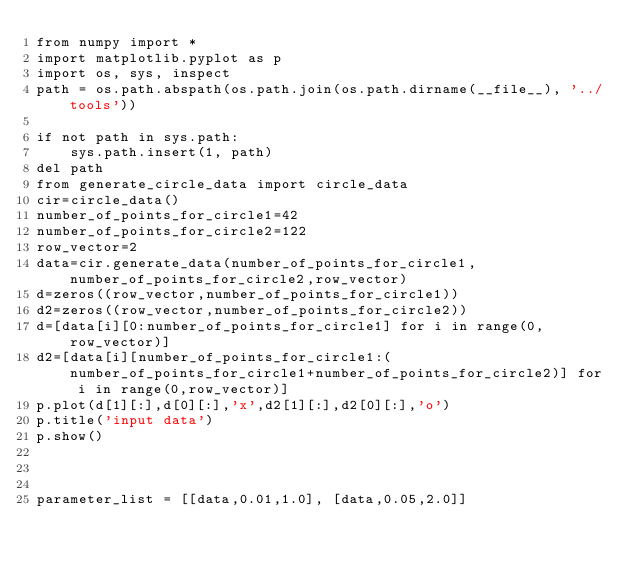<code> <loc_0><loc_0><loc_500><loc_500><_Python_>from numpy import *
import matplotlib.pyplot as p
import os, sys, inspect
path = os.path.abspath(os.path.join(os.path.dirname(__file__), '../tools'))

if not path in sys.path:
    sys.path.insert(1, path)
del path
from generate_circle_data import circle_data
cir=circle_data()
number_of_points_for_circle1=42
number_of_points_for_circle2=122
row_vector=2
data=cir.generate_data(number_of_points_for_circle1,number_of_points_for_circle2,row_vector)
d=zeros((row_vector,number_of_points_for_circle1))
d2=zeros((row_vector,number_of_points_for_circle2))
d=[data[i][0:number_of_points_for_circle1] for i in range(0,row_vector)]
d2=[data[i][number_of_points_for_circle1:(number_of_points_for_circle1+number_of_points_for_circle2)] for i in range(0,row_vector)]
p.plot(d[1][:],d[0][:],'x',d2[1][:],d2[0][:],'o')
p.title('input data')
p.show()



parameter_list = [[data,0.01,1.0], [data,0.05,2.0]]</code> 